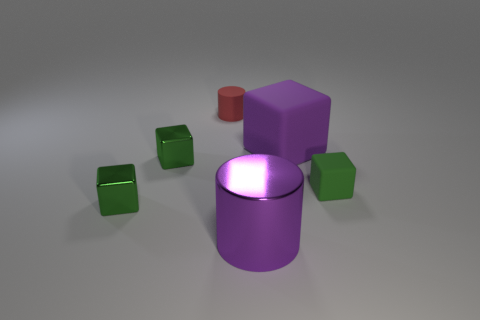How many green blocks must be subtracted to get 1 green blocks? 2 Subtract all cyan cylinders. How many green cubes are left? 3 Subtract all large purple cubes. How many cubes are left? 3 Subtract all purple cubes. How many cubes are left? 3 Add 2 large purple matte objects. How many objects exist? 8 Subtract all blue cubes. Subtract all gray balls. How many cubes are left? 4 Subtract all cylinders. How many objects are left? 4 Subtract 0 red cubes. How many objects are left? 6 Subtract all large purple cylinders. Subtract all tiny objects. How many objects are left? 1 Add 4 metal things. How many metal things are left? 7 